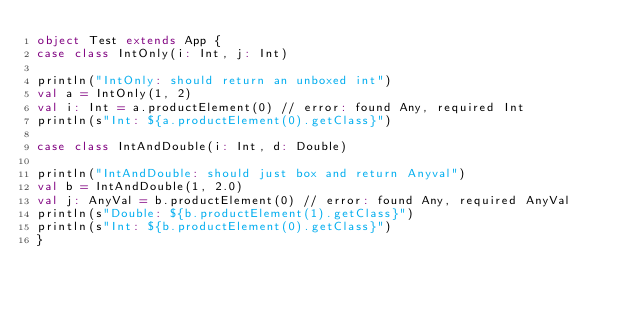<code> <loc_0><loc_0><loc_500><loc_500><_Scala_>object Test extends App {
case class IntOnly(i: Int, j: Int)

println("IntOnly: should return an unboxed int")
val a = IntOnly(1, 2)
val i: Int = a.productElement(0) // error: found Any, required Int
println(s"Int: ${a.productElement(0).getClass}")

case class IntAndDouble(i: Int, d: Double)

println("IntAndDouble: should just box and return Anyval")
val b = IntAndDouble(1, 2.0)
val j: AnyVal = b.productElement(0) // error: found Any, required AnyVal
println(s"Double: ${b.productElement(1).getClass}")
println(s"Int: ${b.productElement(0).getClass}")
}
</code> 